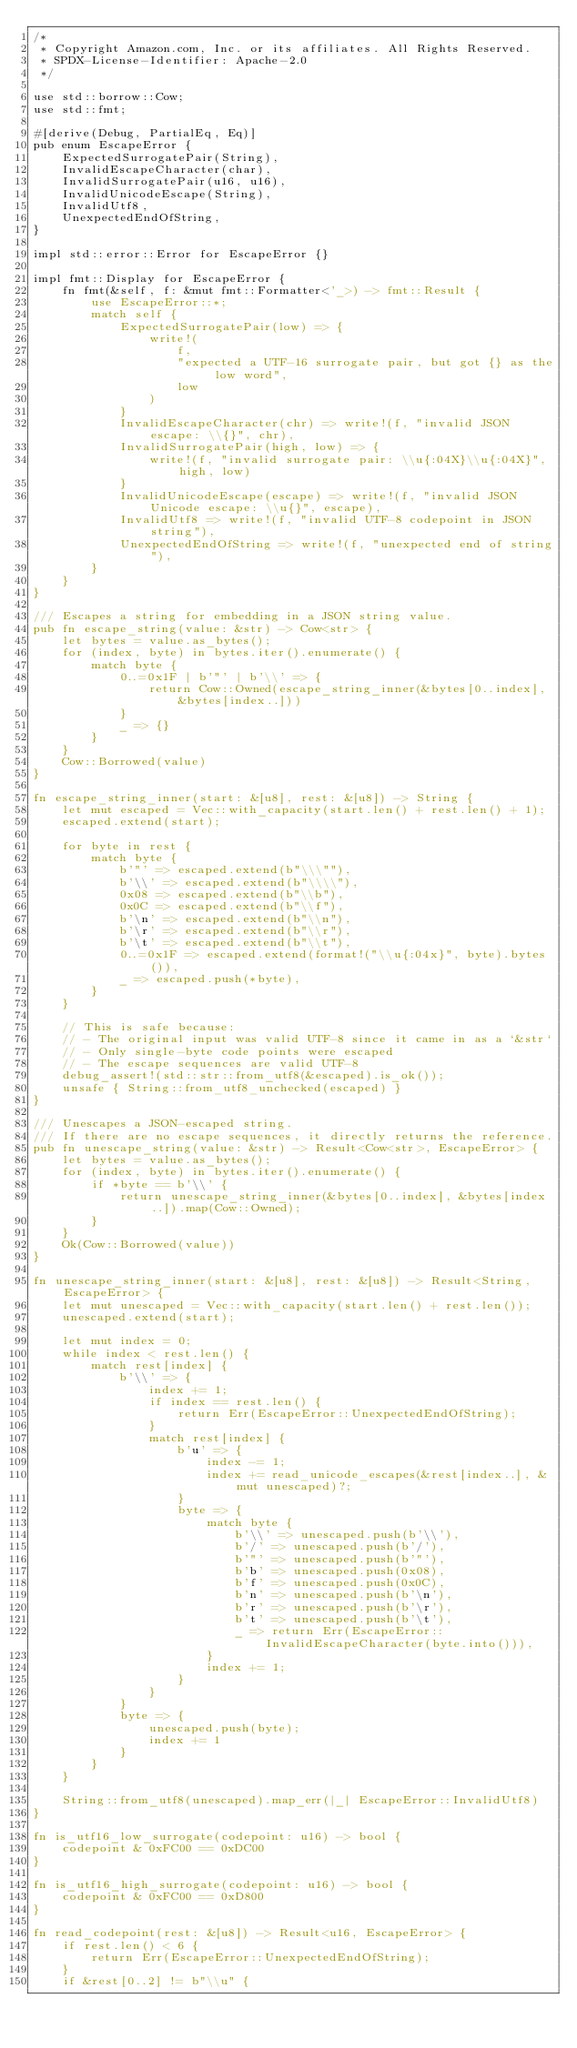Convert code to text. <code><loc_0><loc_0><loc_500><loc_500><_Rust_>/*
 * Copyright Amazon.com, Inc. or its affiliates. All Rights Reserved.
 * SPDX-License-Identifier: Apache-2.0
 */

use std::borrow::Cow;
use std::fmt;

#[derive(Debug, PartialEq, Eq)]
pub enum EscapeError {
    ExpectedSurrogatePair(String),
    InvalidEscapeCharacter(char),
    InvalidSurrogatePair(u16, u16),
    InvalidUnicodeEscape(String),
    InvalidUtf8,
    UnexpectedEndOfString,
}

impl std::error::Error for EscapeError {}

impl fmt::Display for EscapeError {
    fn fmt(&self, f: &mut fmt::Formatter<'_>) -> fmt::Result {
        use EscapeError::*;
        match self {
            ExpectedSurrogatePair(low) => {
                write!(
                    f,
                    "expected a UTF-16 surrogate pair, but got {} as the low word",
                    low
                )
            }
            InvalidEscapeCharacter(chr) => write!(f, "invalid JSON escape: \\{}", chr),
            InvalidSurrogatePair(high, low) => {
                write!(f, "invalid surrogate pair: \\u{:04X}\\u{:04X}", high, low)
            }
            InvalidUnicodeEscape(escape) => write!(f, "invalid JSON Unicode escape: \\u{}", escape),
            InvalidUtf8 => write!(f, "invalid UTF-8 codepoint in JSON string"),
            UnexpectedEndOfString => write!(f, "unexpected end of string"),
        }
    }
}

/// Escapes a string for embedding in a JSON string value.
pub fn escape_string(value: &str) -> Cow<str> {
    let bytes = value.as_bytes();
    for (index, byte) in bytes.iter().enumerate() {
        match byte {
            0..=0x1F | b'"' | b'\\' => {
                return Cow::Owned(escape_string_inner(&bytes[0..index], &bytes[index..]))
            }
            _ => {}
        }
    }
    Cow::Borrowed(value)
}

fn escape_string_inner(start: &[u8], rest: &[u8]) -> String {
    let mut escaped = Vec::with_capacity(start.len() + rest.len() + 1);
    escaped.extend(start);

    for byte in rest {
        match byte {
            b'"' => escaped.extend(b"\\\""),
            b'\\' => escaped.extend(b"\\\\"),
            0x08 => escaped.extend(b"\\b"),
            0x0C => escaped.extend(b"\\f"),
            b'\n' => escaped.extend(b"\\n"),
            b'\r' => escaped.extend(b"\\r"),
            b'\t' => escaped.extend(b"\\t"),
            0..=0x1F => escaped.extend(format!("\\u{:04x}", byte).bytes()),
            _ => escaped.push(*byte),
        }
    }

    // This is safe because:
    // - The original input was valid UTF-8 since it came in as a `&str`
    // - Only single-byte code points were escaped
    // - The escape sequences are valid UTF-8
    debug_assert!(std::str::from_utf8(&escaped).is_ok());
    unsafe { String::from_utf8_unchecked(escaped) }
}

/// Unescapes a JSON-escaped string.
/// If there are no escape sequences, it directly returns the reference.
pub fn unescape_string(value: &str) -> Result<Cow<str>, EscapeError> {
    let bytes = value.as_bytes();
    for (index, byte) in bytes.iter().enumerate() {
        if *byte == b'\\' {
            return unescape_string_inner(&bytes[0..index], &bytes[index..]).map(Cow::Owned);
        }
    }
    Ok(Cow::Borrowed(value))
}

fn unescape_string_inner(start: &[u8], rest: &[u8]) -> Result<String, EscapeError> {
    let mut unescaped = Vec::with_capacity(start.len() + rest.len());
    unescaped.extend(start);

    let mut index = 0;
    while index < rest.len() {
        match rest[index] {
            b'\\' => {
                index += 1;
                if index == rest.len() {
                    return Err(EscapeError::UnexpectedEndOfString);
                }
                match rest[index] {
                    b'u' => {
                        index -= 1;
                        index += read_unicode_escapes(&rest[index..], &mut unescaped)?;
                    }
                    byte => {
                        match byte {
                            b'\\' => unescaped.push(b'\\'),
                            b'/' => unescaped.push(b'/'),
                            b'"' => unescaped.push(b'"'),
                            b'b' => unescaped.push(0x08),
                            b'f' => unescaped.push(0x0C),
                            b'n' => unescaped.push(b'\n'),
                            b'r' => unescaped.push(b'\r'),
                            b't' => unescaped.push(b'\t'),
                            _ => return Err(EscapeError::InvalidEscapeCharacter(byte.into())),
                        }
                        index += 1;
                    }
                }
            }
            byte => {
                unescaped.push(byte);
                index += 1
            }
        }
    }

    String::from_utf8(unescaped).map_err(|_| EscapeError::InvalidUtf8)
}

fn is_utf16_low_surrogate(codepoint: u16) -> bool {
    codepoint & 0xFC00 == 0xDC00
}

fn is_utf16_high_surrogate(codepoint: u16) -> bool {
    codepoint & 0xFC00 == 0xD800
}

fn read_codepoint(rest: &[u8]) -> Result<u16, EscapeError> {
    if rest.len() < 6 {
        return Err(EscapeError::UnexpectedEndOfString);
    }
    if &rest[0..2] != b"\\u" {</code> 